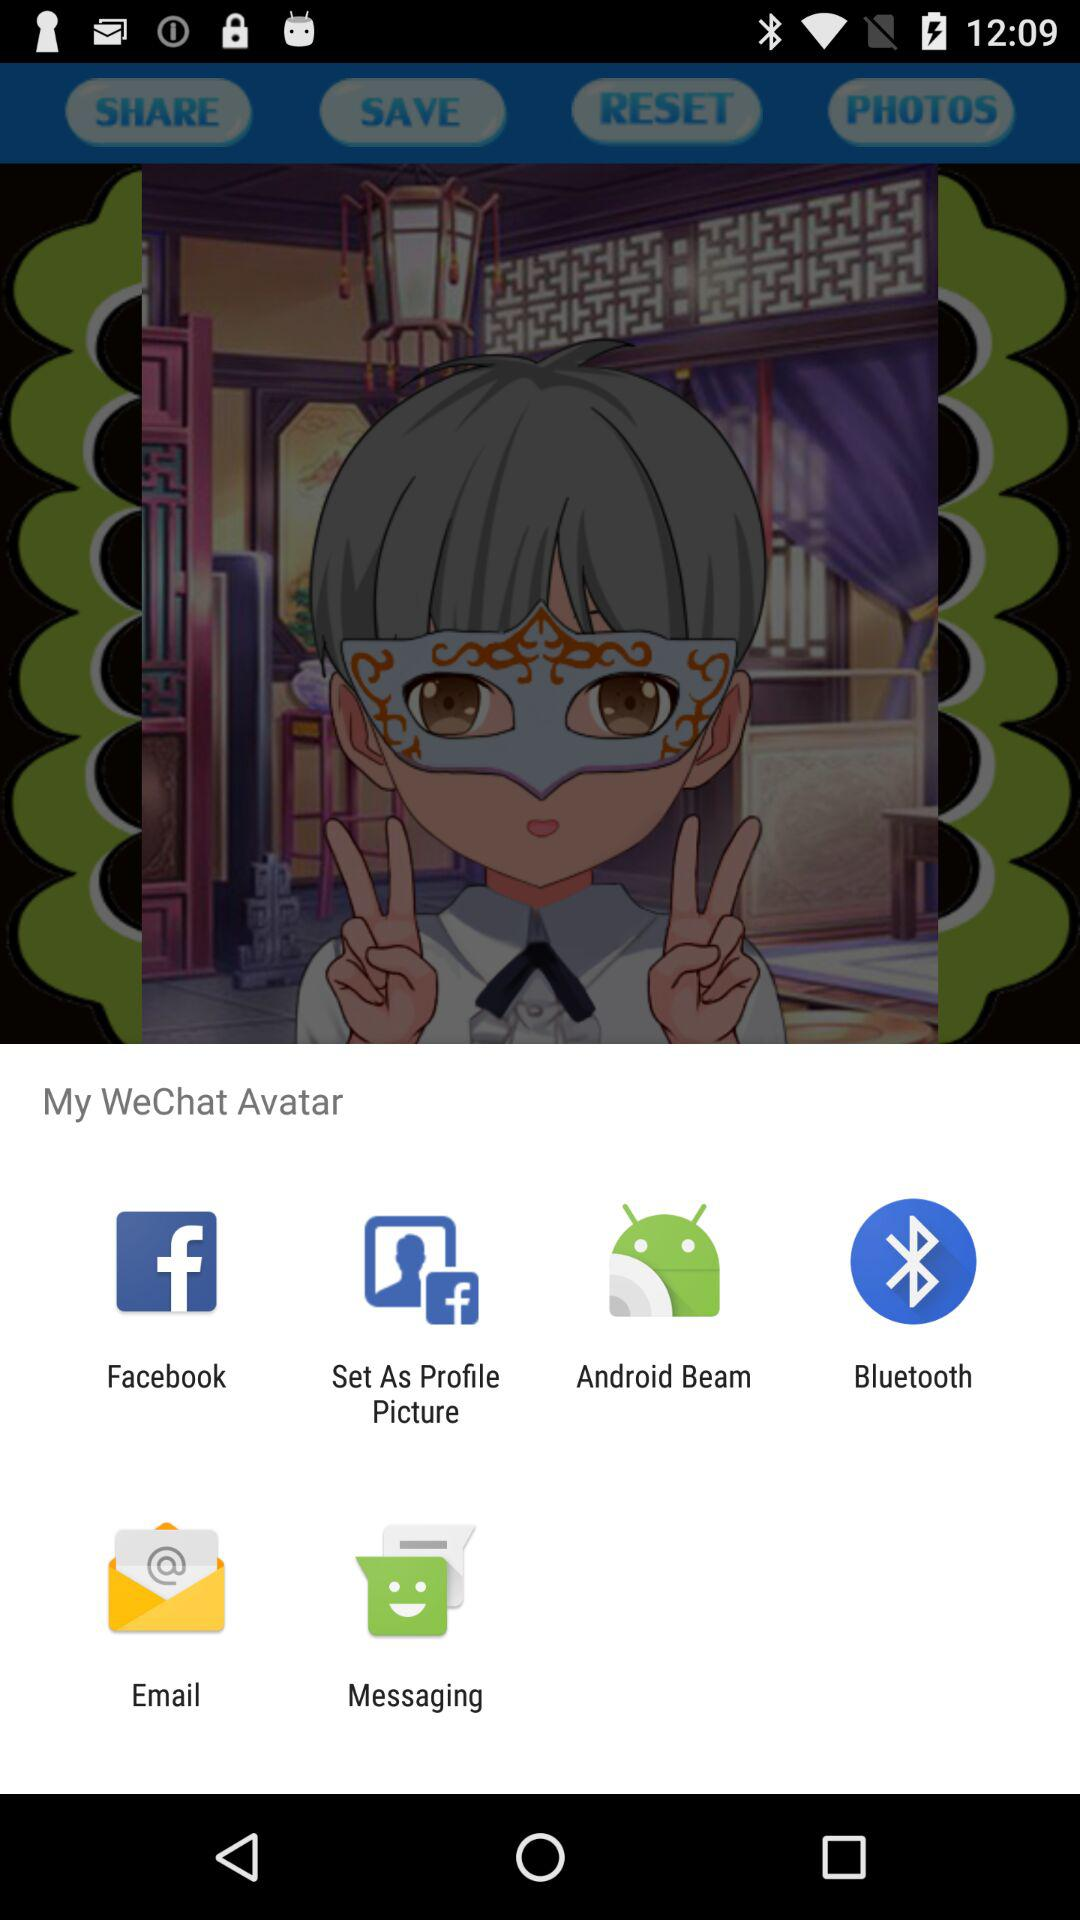Through what application can it be shared? The applications are "Facebook", "Set As Profile Picture", "Android Beam", "Bluetooth", "Email", and "Messaging". 